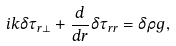Convert formula to latex. <formula><loc_0><loc_0><loc_500><loc_500>i k \delta \tau _ { r \perp } + \frac { d } { d r } \delta \tau _ { r r } = \delta \rho g ,</formula> 